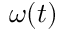<formula> <loc_0><loc_0><loc_500><loc_500>\omega ( t )</formula> 